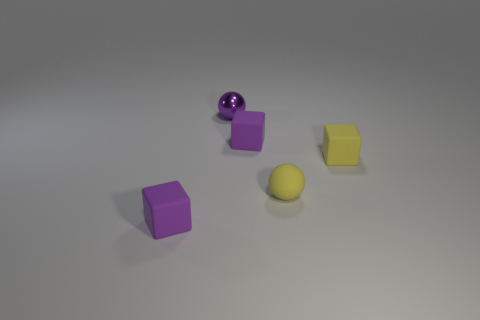Subtract all tiny purple cubes. How many cubes are left? 1 Add 3 small blue metallic cylinders. How many objects exist? 8 Subtract all spheres. How many objects are left? 3 Subtract all green metallic objects. Subtract all small purple shiny balls. How many objects are left? 4 Add 1 tiny yellow objects. How many tiny yellow objects are left? 3 Add 1 small metal spheres. How many small metal spheres exist? 2 Subtract 0 cyan cubes. How many objects are left? 5 